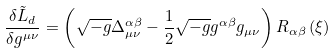Convert formula to latex. <formula><loc_0><loc_0><loc_500><loc_500>\frac { \delta \tilde { L } _ { d } } { \delta g ^ { \mu \nu } } = \left ( \sqrt { - g } \Delta _ { \mu \nu } ^ { \alpha \beta } - \frac { 1 } { 2 } \sqrt { - g } g ^ { \alpha \beta } g _ { \mu \nu } \right ) R _ { \alpha \beta } \left ( \xi \right )</formula> 